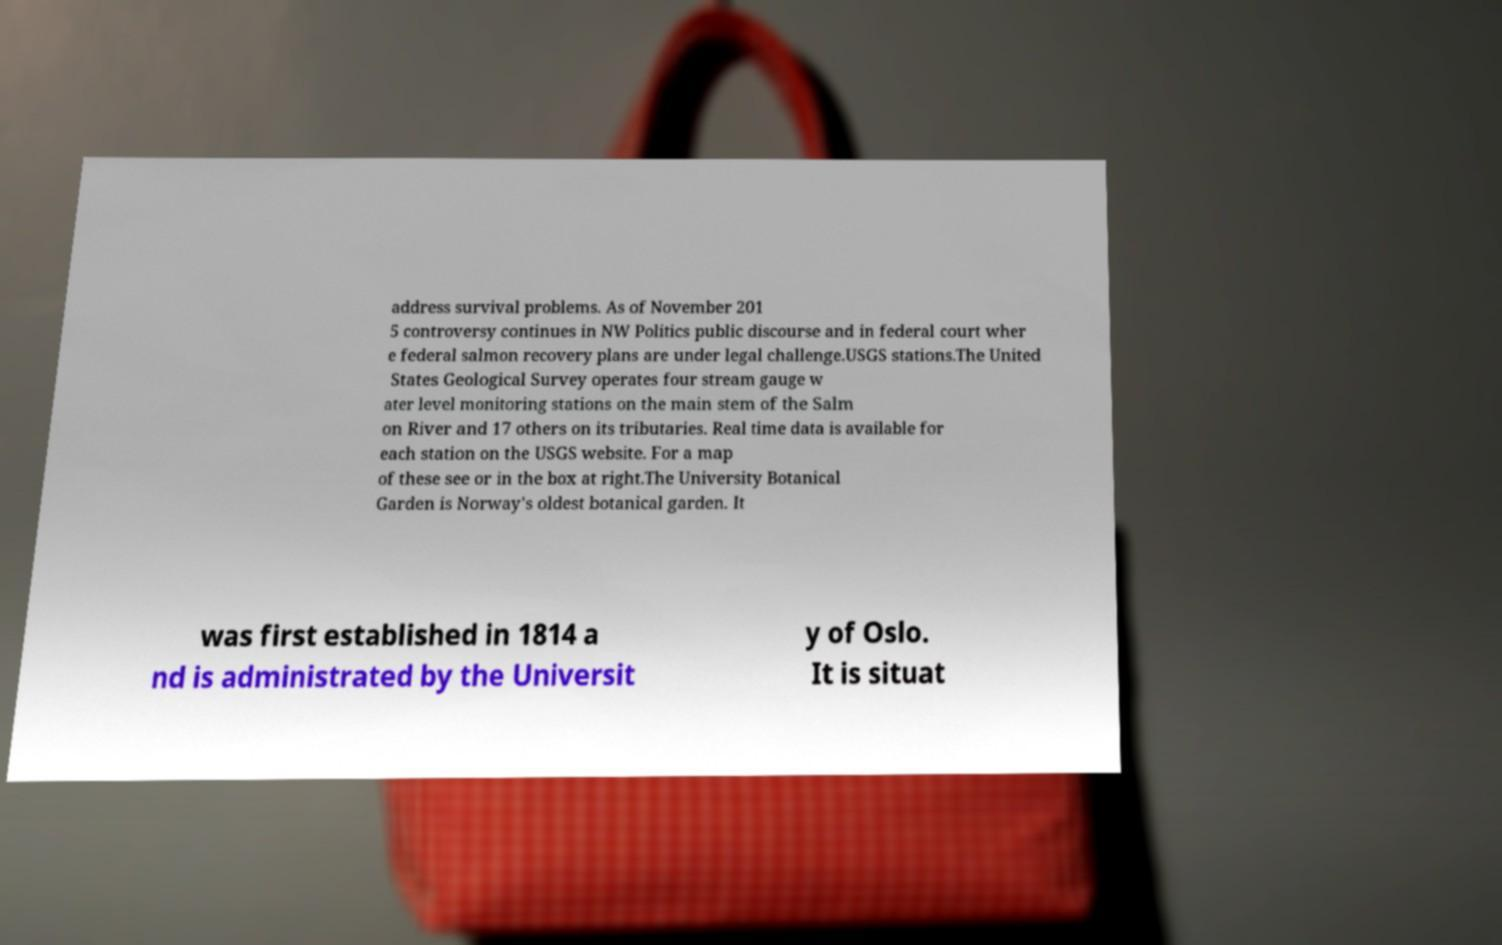Please read and relay the text visible in this image. What does it say? address survival problems. As of November 201 5 controversy continues in NW Politics public discourse and in federal court wher e federal salmon recovery plans are under legal challenge.USGS stations.The United States Geological Survey operates four stream gauge w ater level monitoring stations on the main stem of the Salm on River and 17 others on its tributaries. Real time data is available for each station on the USGS website. For a map of these see or in the box at right.The University Botanical Garden is Norway's oldest botanical garden. It was first established in 1814 a nd is administrated by the Universit y of Oslo. It is situat 